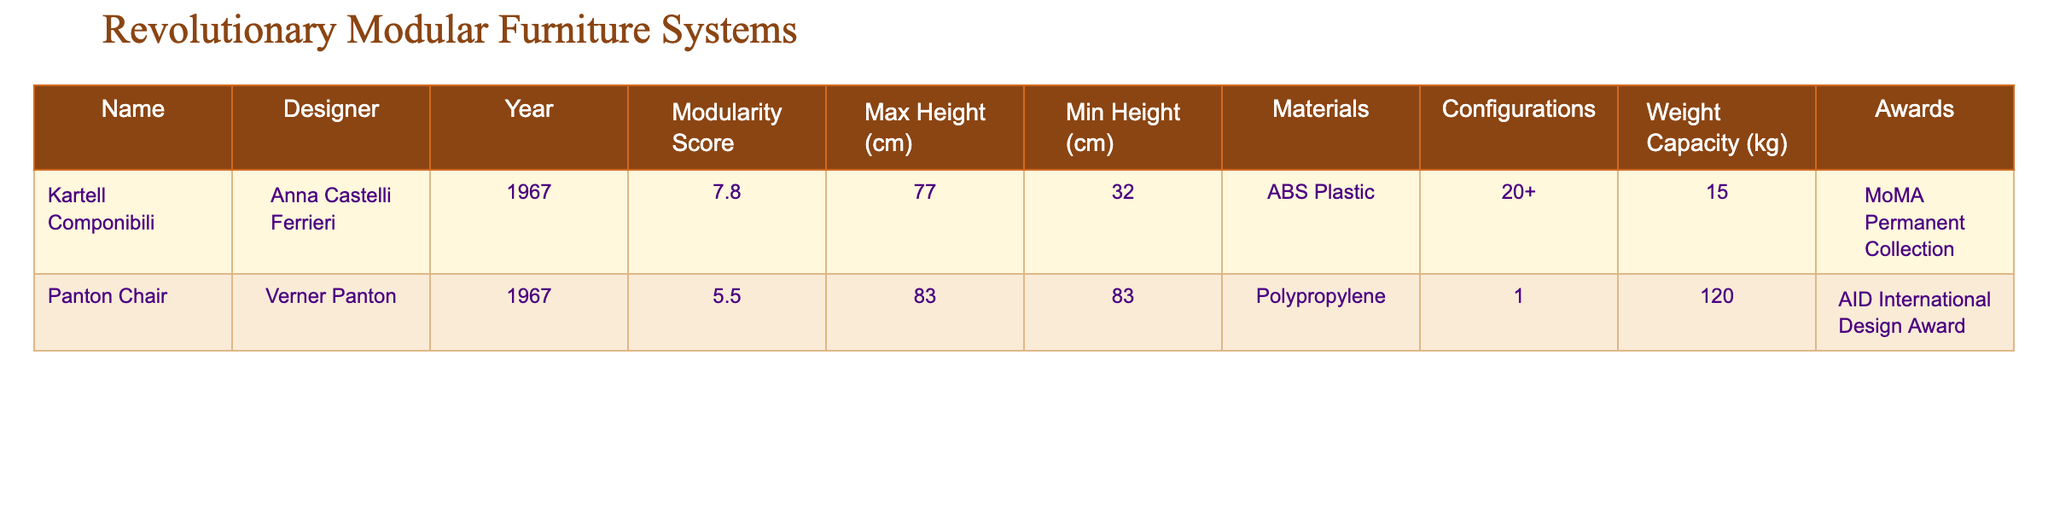What is the maximum height of the Kartell Componibili? The table shows that the maximum height of the Kartell Componibili is listed as 77 cm.
Answer: 77 cm What material is used in the Panton Chair? According to the table, the Panton Chair is made of polypropylene.
Answer: Polypropylene Which designer created the Kartell Componibili? The designer of the Kartell Componibili, as shown in the table, is Anna Castelli Ferrieri.
Answer: Anna Castelli Ferrieri What is the Modularity Score of the Panton Chair? The table indicates that the Modularity Score for the Panton Chair is 5.5.
Answer: 5.5 Is the Kartell Componibili part of a permanent collection? Yes, the table notes that the Kartell Componibili is part of the MoMA Permanent Collection, so this statement is true.
Answer: Yes What is the weight capacity of the Kartell Componibili? The table states that the weight capacity of the Kartell Componibili is 15 kg.
Answer: 15 kg How much taller is the maximum height of the Kartell Componibili compared to its minimum height? The maximum height is 77 cm and the minimum height is 32 cm; thus, the difference is 77 - 32 = 45 cm.
Answer: 45 cm What is the combined weight capacity of both furniture pieces? The weight capacities of the Kartell Componibili and the Panton Chair are 15 kg and 120 kg respectively. Adding them gives 15 + 120 = 135 kg.
Answer: 135 kg Is there a configuration option for the Panton Chair? No, the table states that the Panton Chair has only 1 configuration option, meaning it does not have multiple configuration choices available.
Answer: No What award did the Panton Chair receive? The table lists that the Panton Chair received the AID International Design Award.
Answer: AID International Design Award Which piece of furniture has a higher weight capacity, Kartell Componibili or Panton Chair? The Panton Chair has a weight capacity of 120 kg, while the Kartell Componibili has a weight capacity of 15 kg. Therefore, the Panton Chair has a higher weight capacity.
Answer: Panton Chair 